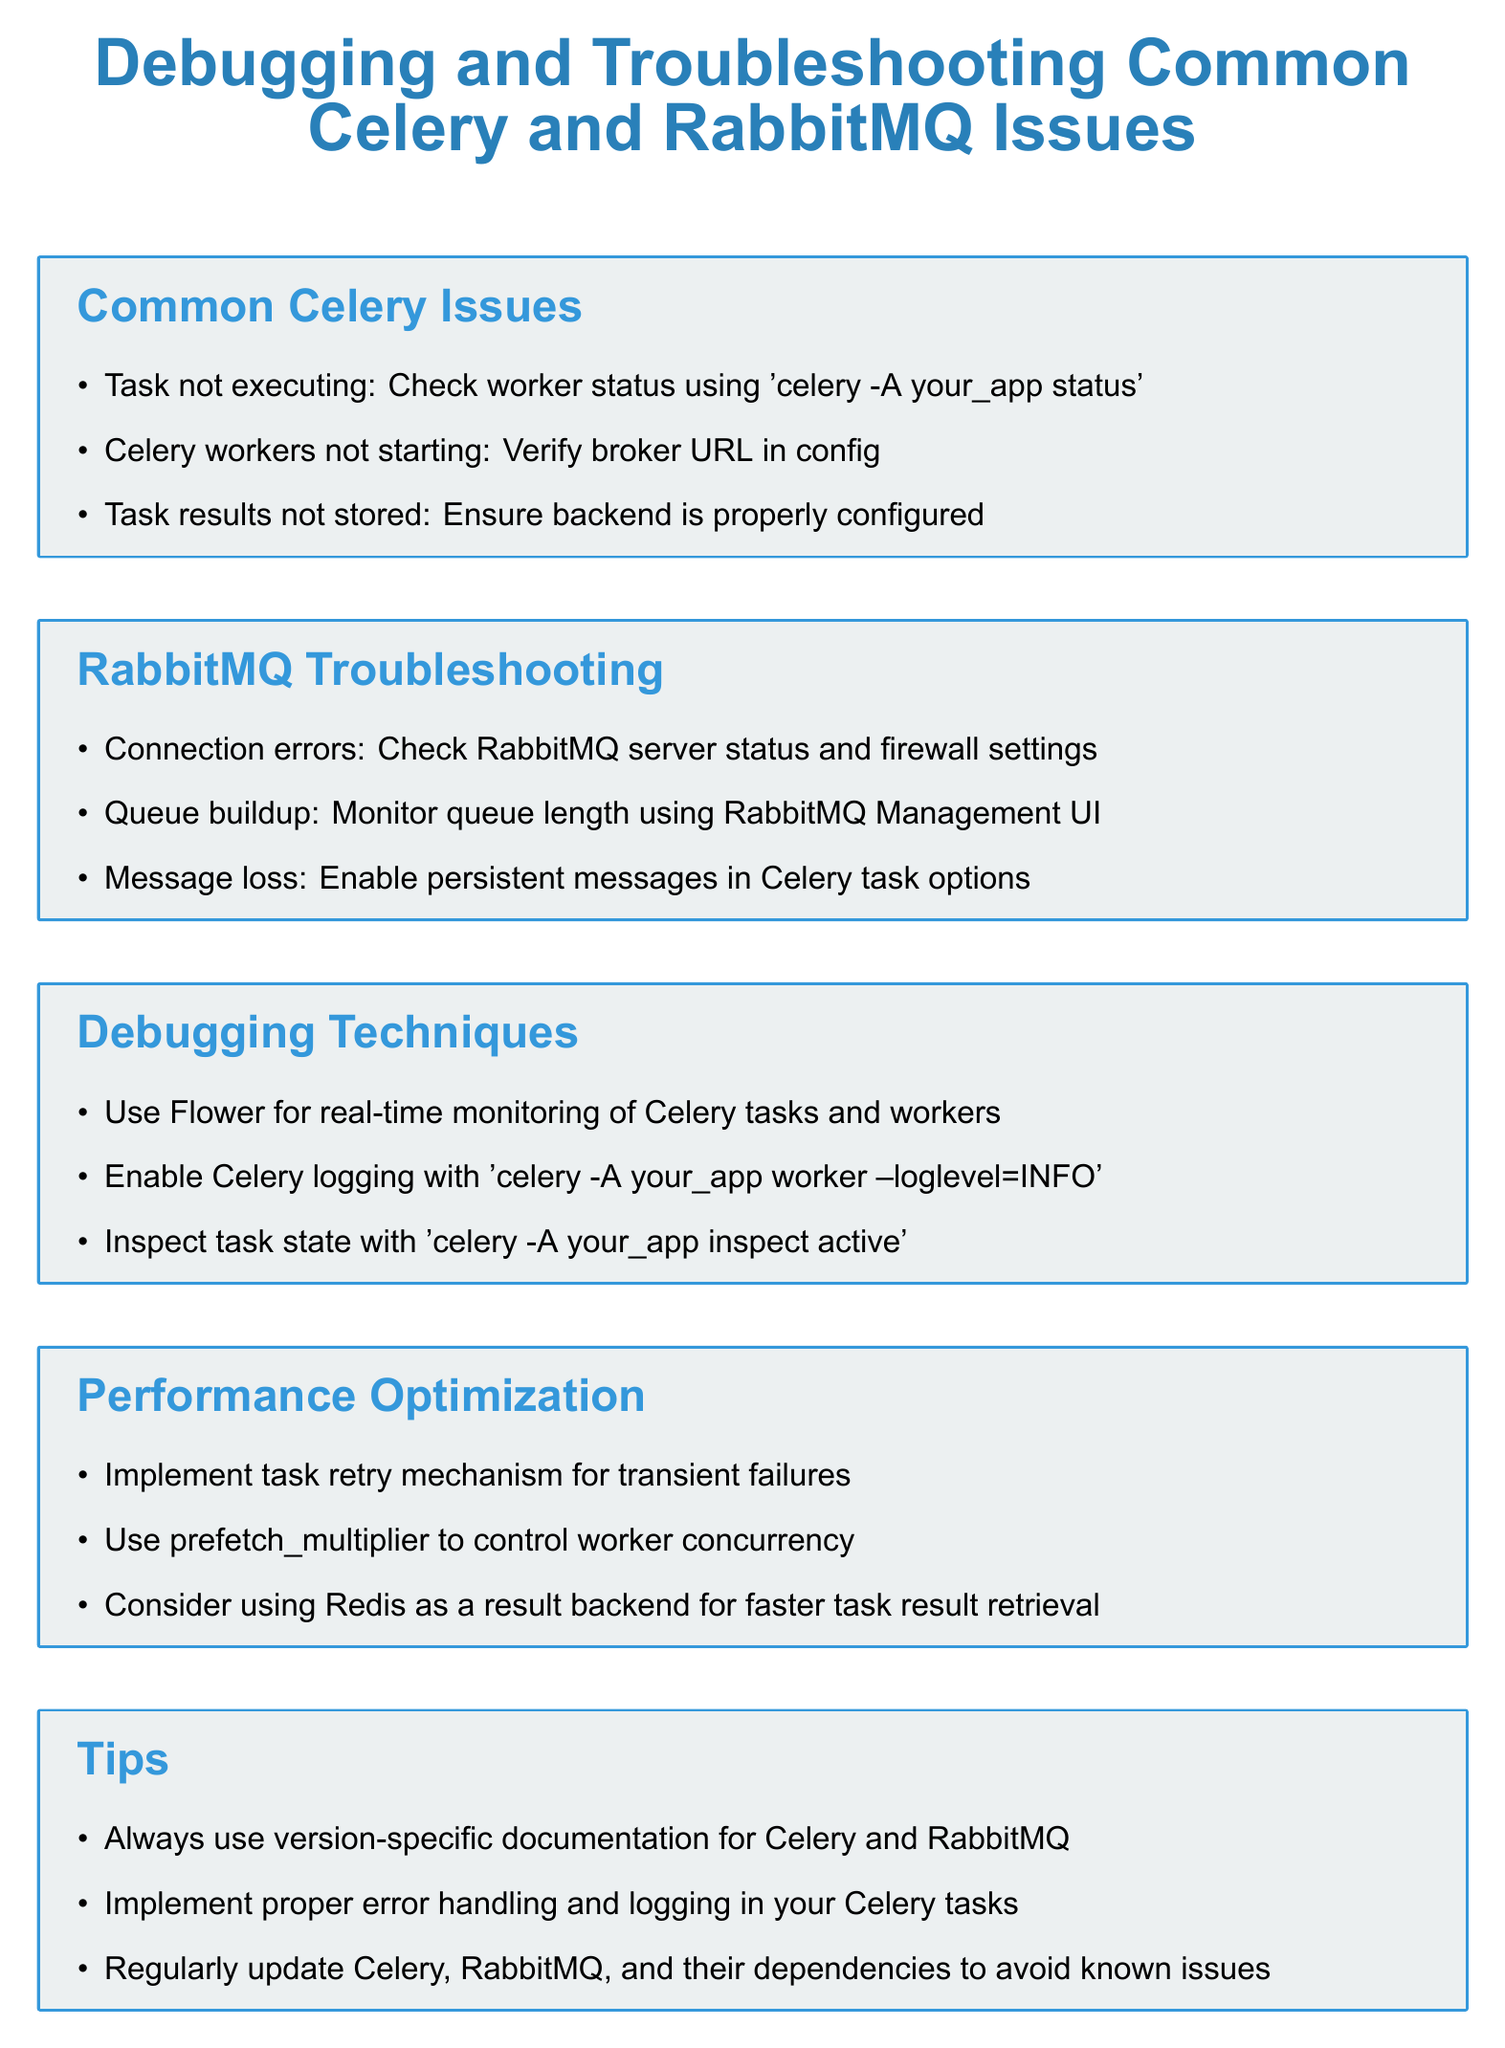What command checks worker status? The document states that the command to check worker status is 'celery -A your_app status'.
Answer: 'celery -A your_app status' What is recommended for monitoring queues? The document suggests monitoring queue length using RabbitMQ Management UI for observing queue buildup.
Answer: RabbitMQ Management UI What is a technique for real-time monitoring? The document mentions using Flower for real-time monitoring of Celery tasks and workers as a technique.
Answer: Flower How can message loss be prevented? The document advises enabling persistent messages in Celery task options to prevent message loss.
Answer: Enable persistent messages What factor can control worker concurrency? The document indicates using prefetch_multiplier to control worker concurrency as a factor.
Answer: prefetch_multiplier 